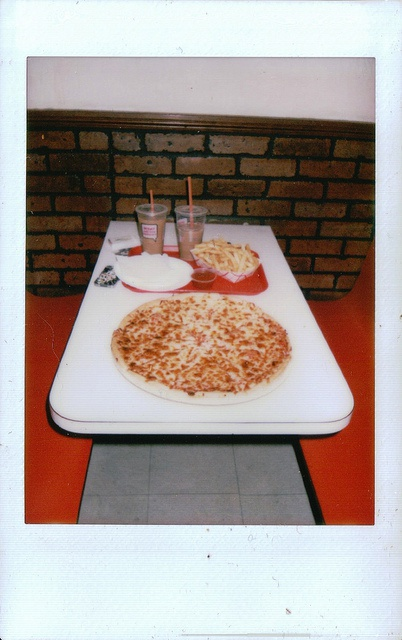Describe the objects in this image and their specific colors. I can see dining table in lavender, lightgray, tan, salmon, and darkgray tones, pizza in lavender, tan, brown, and salmon tones, bench in lavender, brown, maroon, lightgray, and black tones, bench in lavender, brown, maroon, black, and lightgray tones, and cup in lavender, gray, and maroon tones in this image. 